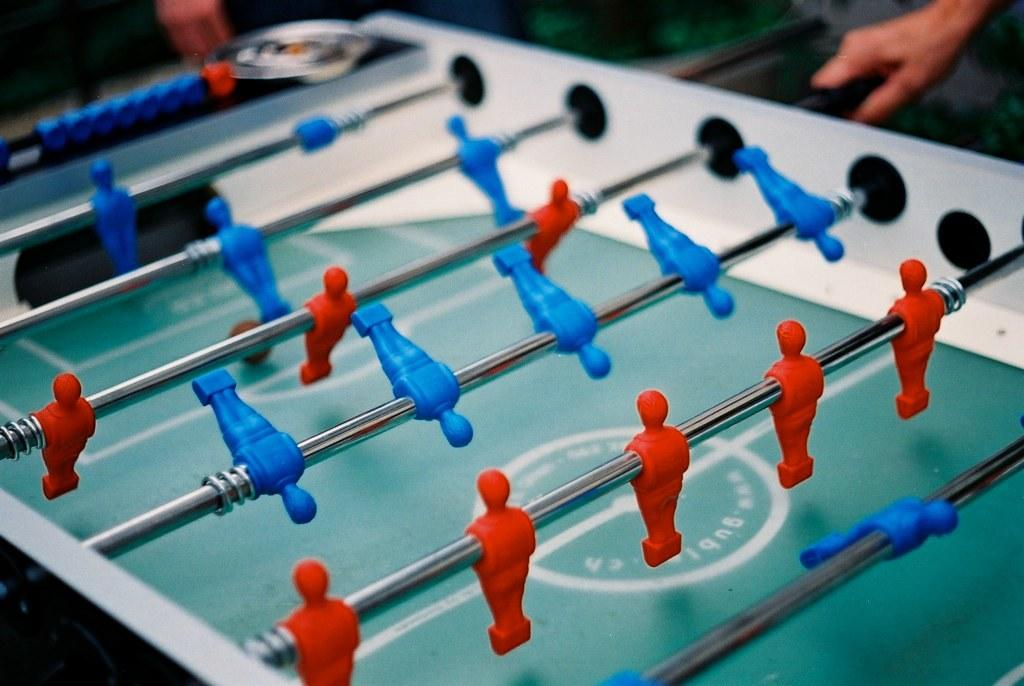What type of game can be played on the table in the image? There is a foosball table in the image, which is used for playing foosball. Can you describe any human presence in the image? A person's hand is visible at the top of the image. How many lizards are playing baseball on the foosball table in the image? There are no lizards or baseball game depicted in the image; it features a foosball table and a person's hand. 